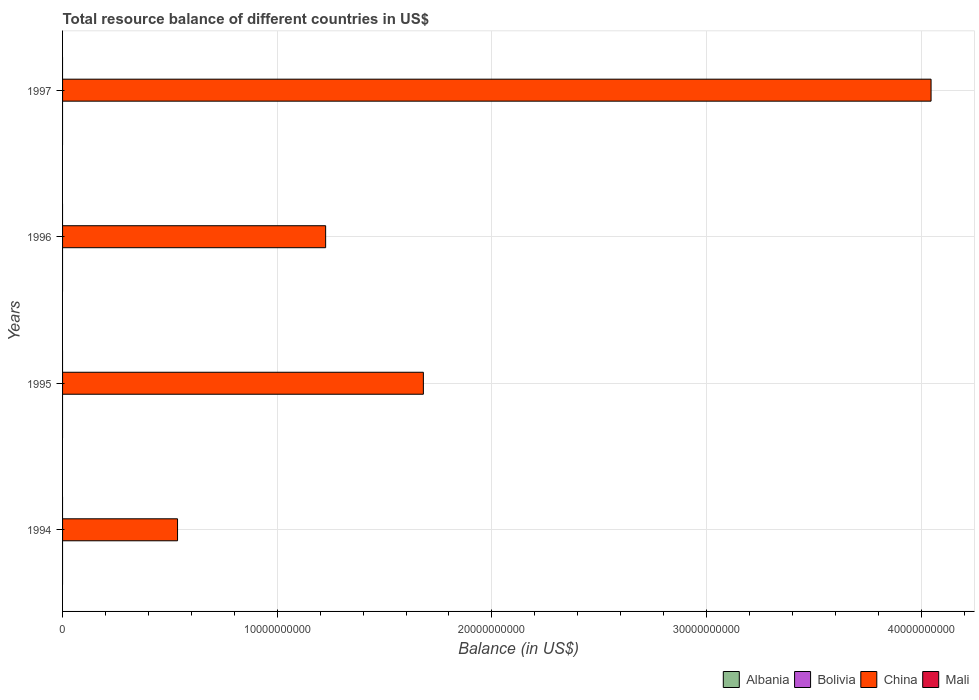How many different coloured bars are there?
Give a very brief answer. 1. How many bars are there on the 1st tick from the top?
Your answer should be compact. 1. What is the label of the 2nd group of bars from the top?
Provide a short and direct response. 1996. In how many cases, is the number of bars for a given year not equal to the number of legend labels?
Your answer should be very brief. 4. What is the total resource balance in Albania in 1997?
Keep it short and to the point. 0. Across all years, what is the maximum total resource balance in China?
Your response must be concise. 4.05e+1. Across all years, what is the minimum total resource balance in Albania?
Your answer should be compact. 0. In which year was the total resource balance in China maximum?
Your answer should be very brief. 1997. What is the difference between the total resource balance in China in 1996 and that in 1997?
Your response must be concise. -2.82e+1. What is the average total resource balance in Bolivia per year?
Make the answer very short. 0. In how many years, is the total resource balance in China greater than 16000000000 US$?
Provide a succinct answer. 2. Is the sum of the total resource balance in China in 1994 and 1997 greater than the maximum total resource balance in Mali across all years?
Provide a succinct answer. Yes. Is it the case that in every year, the sum of the total resource balance in Albania and total resource balance in Mali is greater than the total resource balance in Bolivia?
Offer a very short reply. No. Are the values on the major ticks of X-axis written in scientific E-notation?
Offer a terse response. No. Does the graph contain any zero values?
Offer a terse response. Yes. Where does the legend appear in the graph?
Offer a very short reply. Bottom right. How are the legend labels stacked?
Provide a succinct answer. Horizontal. What is the title of the graph?
Ensure brevity in your answer.  Total resource balance of different countries in US$. What is the label or title of the X-axis?
Give a very brief answer. Balance (in US$). What is the label or title of the Y-axis?
Provide a short and direct response. Years. What is the Balance (in US$) of Bolivia in 1994?
Make the answer very short. 0. What is the Balance (in US$) of China in 1994?
Make the answer very short. 5.36e+09. What is the Balance (in US$) of Mali in 1994?
Ensure brevity in your answer.  0. What is the Balance (in US$) of Bolivia in 1995?
Give a very brief answer. 0. What is the Balance (in US$) of China in 1995?
Ensure brevity in your answer.  1.68e+1. What is the Balance (in US$) in Mali in 1995?
Give a very brief answer. 0. What is the Balance (in US$) in China in 1996?
Ensure brevity in your answer.  1.23e+1. What is the Balance (in US$) in Mali in 1996?
Give a very brief answer. 0. What is the Balance (in US$) in Bolivia in 1997?
Your response must be concise. 0. What is the Balance (in US$) in China in 1997?
Keep it short and to the point. 4.05e+1. Across all years, what is the maximum Balance (in US$) of China?
Keep it short and to the point. 4.05e+1. Across all years, what is the minimum Balance (in US$) in China?
Offer a terse response. 5.36e+09. What is the total Balance (in US$) of Bolivia in the graph?
Your answer should be compact. 0. What is the total Balance (in US$) in China in the graph?
Your answer should be very brief. 7.49e+1. What is the difference between the Balance (in US$) of China in 1994 and that in 1995?
Ensure brevity in your answer.  -1.15e+1. What is the difference between the Balance (in US$) in China in 1994 and that in 1996?
Provide a succinct answer. -6.90e+09. What is the difference between the Balance (in US$) of China in 1994 and that in 1997?
Ensure brevity in your answer.  -3.51e+1. What is the difference between the Balance (in US$) of China in 1995 and that in 1996?
Give a very brief answer. 4.55e+09. What is the difference between the Balance (in US$) of China in 1995 and that in 1997?
Your answer should be very brief. -2.37e+1. What is the difference between the Balance (in US$) in China in 1996 and that in 1997?
Provide a short and direct response. -2.82e+1. What is the average Balance (in US$) in Bolivia per year?
Your answer should be compact. 0. What is the average Balance (in US$) in China per year?
Offer a very short reply. 1.87e+1. What is the average Balance (in US$) of Mali per year?
Ensure brevity in your answer.  0. What is the ratio of the Balance (in US$) in China in 1994 to that in 1995?
Give a very brief answer. 0.32. What is the ratio of the Balance (in US$) in China in 1994 to that in 1996?
Provide a short and direct response. 0.44. What is the ratio of the Balance (in US$) of China in 1994 to that in 1997?
Offer a very short reply. 0.13. What is the ratio of the Balance (in US$) of China in 1995 to that in 1996?
Your answer should be very brief. 1.37. What is the ratio of the Balance (in US$) of China in 1995 to that in 1997?
Your response must be concise. 0.42. What is the ratio of the Balance (in US$) in China in 1996 to that in 1997?
Offer a terse response. 0.3. What is the difference between the highest and the second highest Balance (in US$) of China?
Give a very brief answer. 2.37e+1. What is the difference between the highest and the lowest Balance (in US$) in China?
Your response must be concise. 3.51e+1. 